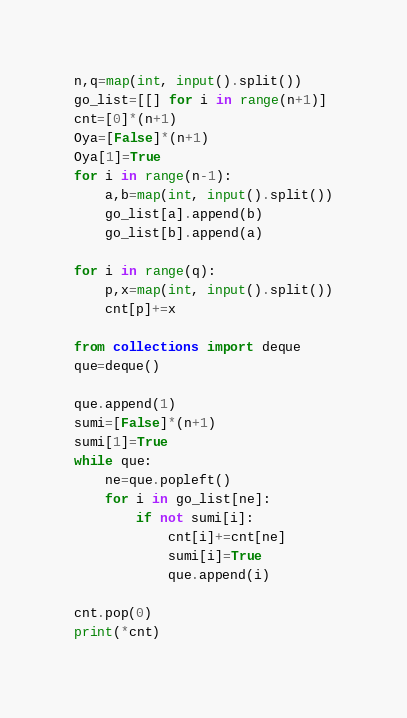Convert code to text. <code><loc_0><loc_0><loc_500><loc_500><_Python_>n,q=map(int, input().split())
go_list=[[] for i in range(n+1)]
cnt=[0]*(n+1)
Oya=[False]*(n+1)
Oya[1]=True
for i in range(n-1):
    a,b=map(int, input().split())
    go_list[a].append(b)
    go_list[b].append(a)

for i in range(q):
    p,x=map(int, input().split())
    cnt[p]+=x

from collections import deque
que=deque()

que.append(1)
sumi=[False]*(n+1)
sumi[1]=True
while que:
    ne=que.popleft()
    for i in go_list[ne]:
        if not sumi[i]:
            cnt[i]+=cnt[ne]
            sumi[i]=True
            que.append(i)

cnt.pop(0)
print(*cnt)</code> 